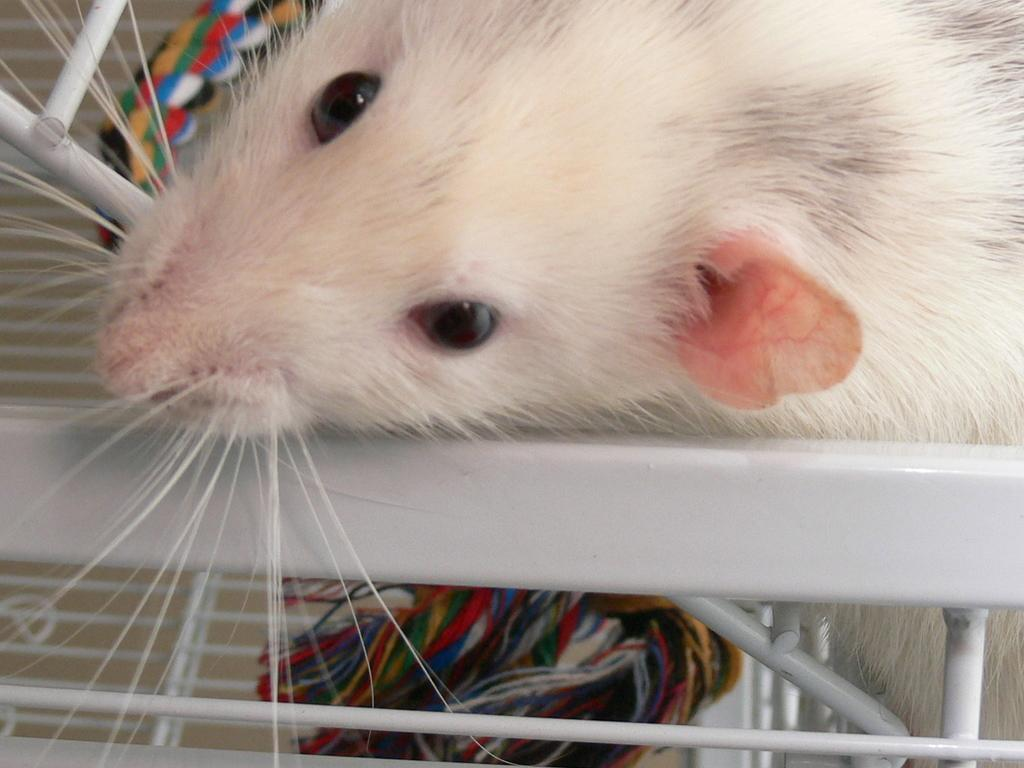What type of animal is present in the image? There is a rat in the image. What color is the rat? The rat is white in color. What other items can be seen in the image besides the rat? There are colorful threads and a metal object in the image. How many cents are visible in the image? There is no mention of any currency or coins in the image, so it is not possible to determine the number of cents. 